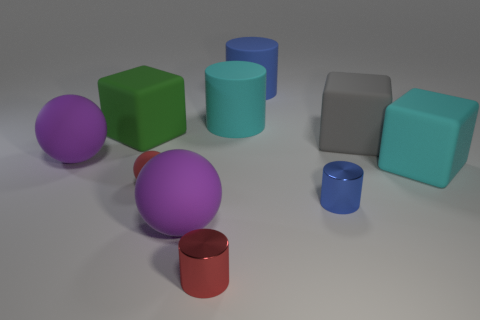Is there anything else that has the same size as the red metal object?
Offer a very short reply. Yes. What number of blue matte spheres are the same size as the red cylinder?
Ensure brevity in your answer.  0. There is a purple object that is in front of the red matte object; does it have the same shape as the red metallic object in front of the gray matte block?
Your response must be concise. No. There is a object that is the same color as the tiny rubber ball; what is its shape?
Make the answer very short. Cylinder. There is a large matte ball that is behind the large cyan object right of the cyan rubber cylinder; what is its color?
Ensure brevity in your answer.  Purple. There is another tiny shiny object that is the same shape as the blue metallic thing; what color is it?
Offer a terse response. Red. Is there anything else that has the same material as the large cyan block?
Keep it short and to the point. Yes. There is a cyan thing that is the same shape as the big green rubber thing; what is its size?
Make the answer very short. Large. There is a tiny object to the right of the red shiny object; what is its material?
Make the answer very short. Metal. Are there fewer large spheres behind the large gray rubber thing than blue cylinders?
Provide a succinct answer. Yes. 